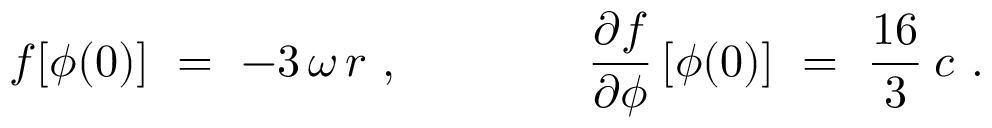<formula> <loc_0><loc_0><loc_500><loc_500>f [ \phi ( 0 ) ] \ = \ - 3 \, \omega \, r \ , \quad \frac { \partial f } { \partial \phi } \, [ \phi ( 0 ) ] \ = \ \frac { 1 6 } { 3 } \, c \ .</formula> 